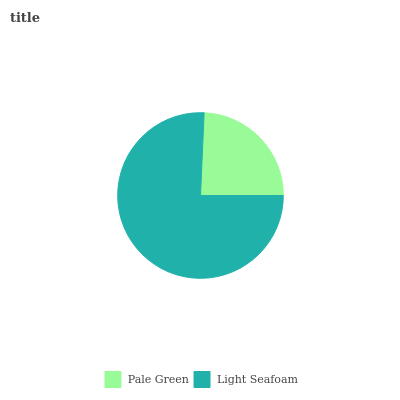Is Pale Green the minimum?
Answer yes or no. Yes. Is Light Seafoam the maximum?
Answer yes or no. Yes. Is Light Seafoam the minimum?
Answer yes or no. No. Is Light Seafoam greater than Pale Green?
Answer yes or no. Yes. Is Pale Green less than Light Seafoam?
Answer yes or no. Yes. Is Pale Green greater than Light Seafoam?
Answer yes or no. No. Is Light Seafoam less than Pale Green?
Answer yes or no. No. Is Light Seafoam the high median?
Answer yes or no. Yes. Is Pale Green the low median?
Answer yes or no. Yes. Is Pale Green the high median?
Answer yes or no. No. Is Light Seafoam the low median?
Answer yes or no. No. 